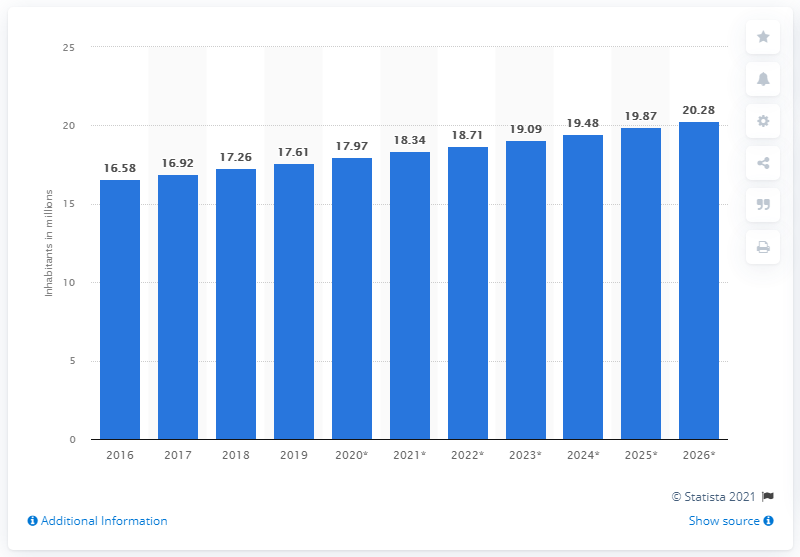Specify some key components in this picture. In 2019, the population of Guatemala was 17.61 million. 